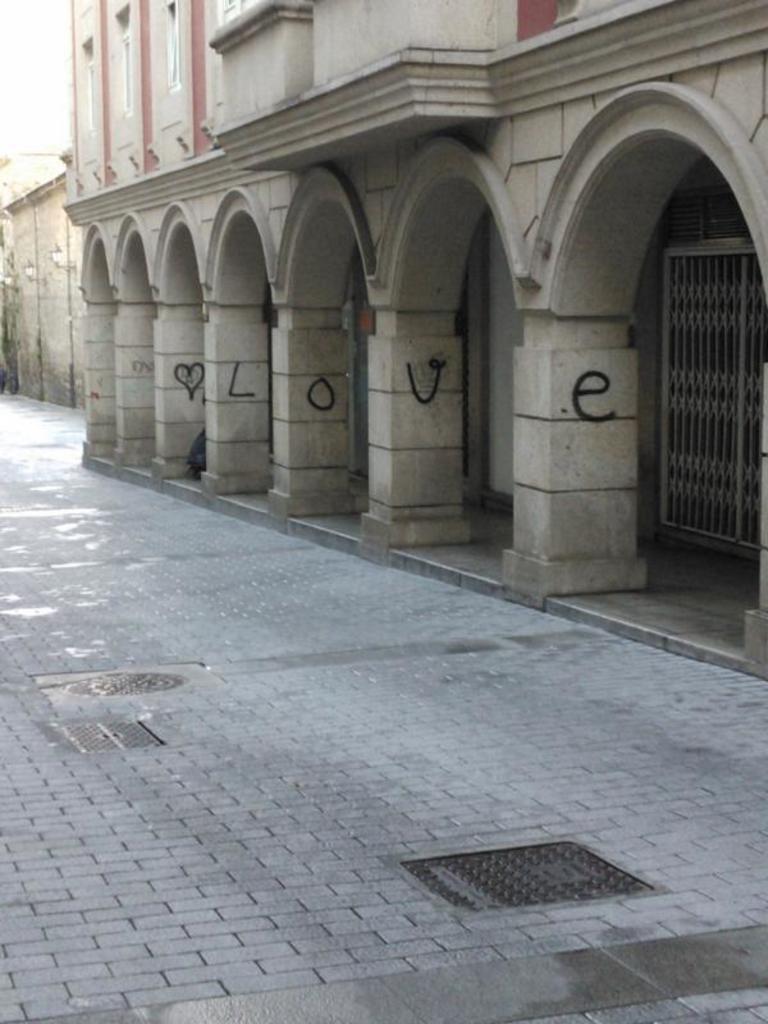Can you describe this image briefly? In this image in front there is a floor. In the background of the image there are buildings. 